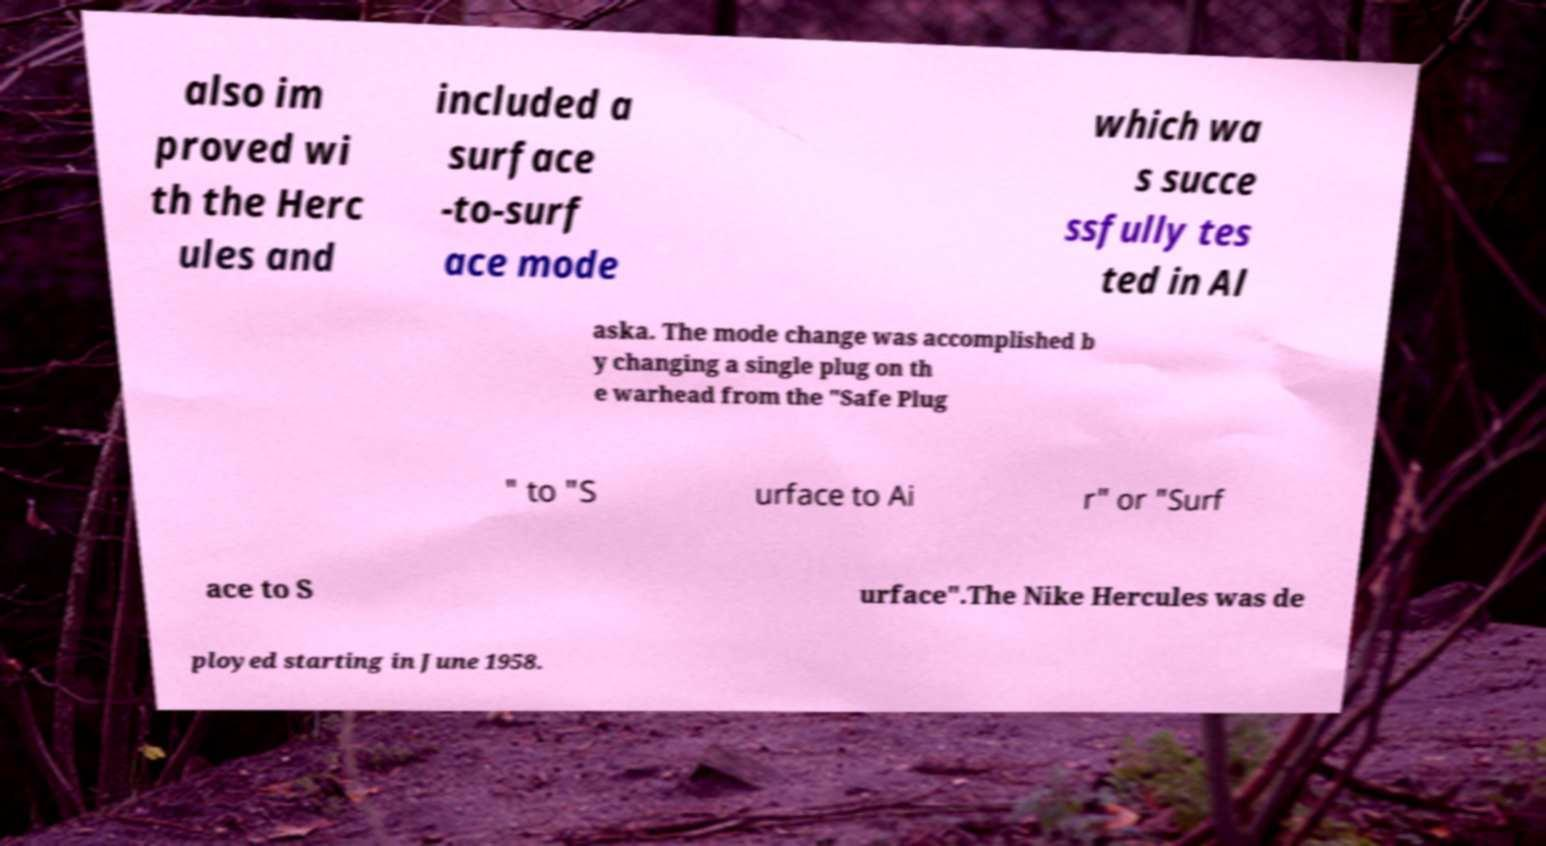Can you accurately transcribe the text from the provided image for me? also im proved wi th the Herc ules and included a surface -to-surf ace mode which wa s succe ssfully tes ted in Al aska. The mode change was accomplished b y changing a single plug on th e warhead from the "Safe Plug " to "S urface to Ai r" or "Surf ace to S urface".The Nike Hercules was de ployed starting in June 1958. 